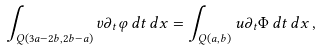Convert formula to latex. <formula><loc_0><loc_0><loc_500><loc_500>\int _ { Q ( 3 a - 2 b , 2 b - a ) } v \partial _ { t } \varphi \, d t \, d x = \int _ { Q ( a , b ) } u \partial _ { t } \Phi \, d t \, d x \, ,</formula> 